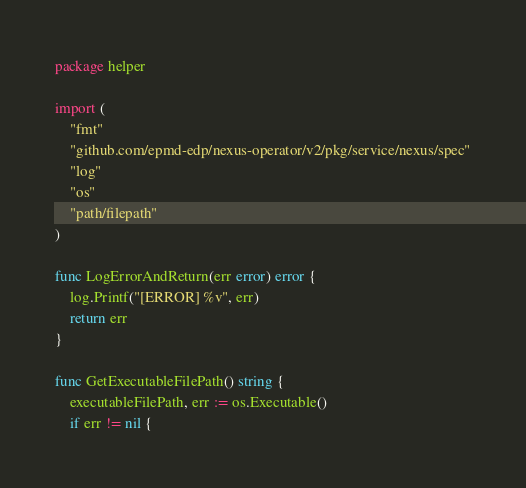Convert code to text. <code><loc_0><loc_0><loc_500><loc_500><_Go_>package helper

import (
	"fmt"
	"github.com/epmd-edp/nexus-operator/v2/pkg/service/nexus/spec"
	"log"
	"os"
	"path/filepath"
)

func LogErrorAndReturn(err error) error {
	log.Printf("[ERROR] %v", err)
	return err
}

func GetExecutableFilePath() string {
	executableFilePath, err := os.Executable()
	if err != nil {</code> 